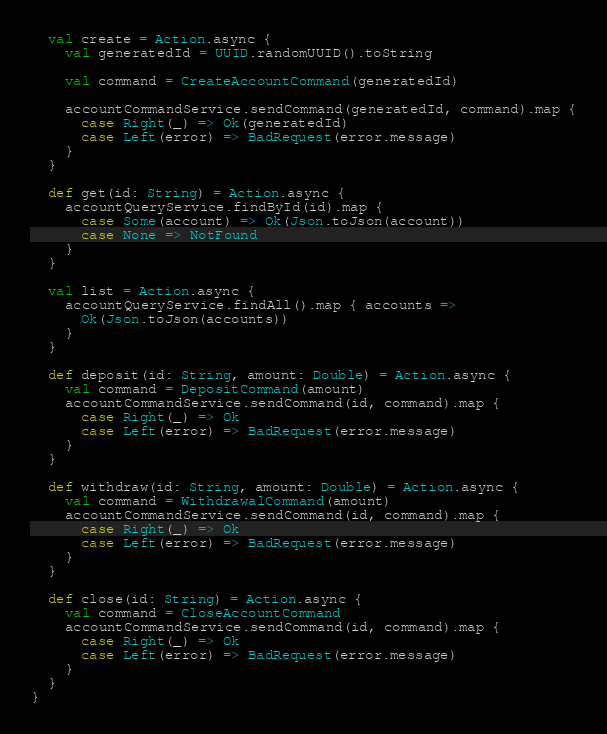Convert code to text. <code><loc_0><loc_0><loc_500><loc_500><_Scala_>
  val create = Action.async {
    val generatedId = UUID.randomUUID().toString

    val command = CreateAccountCommand(generatedId)

    accountCommandService.sendCommand(generatedId, command).map {
      case Right(_) => Ok(generatedId)
      case Left(error) => BadRequest(error.message)
    }
  }

  def get(id: String) = Action.async {
    accountQueryService.findById(id).map {
      case Some(account) => Ok(Json.toJson(account))
      case None => NotFound
    }
  }

  val list = Action.async {
    accountQueryService.findAll().map { accounts =>
      Ok(Json.toJson(accounts))
    }
  }

  def deposit(id: String, amount: Double) = Action.async {
    val command = DepositCommand(amount)
    accountCommandService.sendCommand(id, command).map {
      case Right(_) => Ok
      case Left(error) => BadRequest(error.message)
    }
  }

  def withdraw(id: String, amount: Double) = Action.async {
    val command = WithdrawalCommand(amount)
    accountCommandService.sendCommand(id, command).map {
      case Right(_) => Ok
      case Left(error) => BadRequest(error.message)
    }
  }

  def close(id: String) = Action.async {
    val command = CloseAccountCommand
    accountCommandService.sendCommand(id, command).map {
      case Right(_) => Ok
      case Left(error) => BadRequest(error.message)
    }
  }
}
</code> 